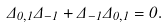<formula> <loc_0><loc_0><loc_500><loc_500>\Delta _ { 0 , 1 } \Delta _ { - 1 } + \Delta _ { - 1 } \Delta _ { 0 , 1 } = 0 .</formula> 